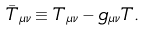Convert formula to latex. <formula><loc_0><loc_0><loc_500><loc_500>\bar { T } _ { \mu \nu } \equiv T _ { \mu \nu } - g _ { \mu \nu } T .</formula> 